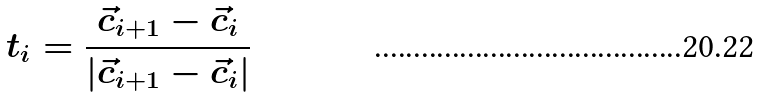Convert formula to latex. <formula><loc_0><loc_0><loc_500><loc_500>t _ { i } = \frac { \vec { c } _ { i + 1 } - \vec { c } _ { i } } { | \vec { c } _ { i + 1 } - \vec { c } _ { i } | } \\</formula> 